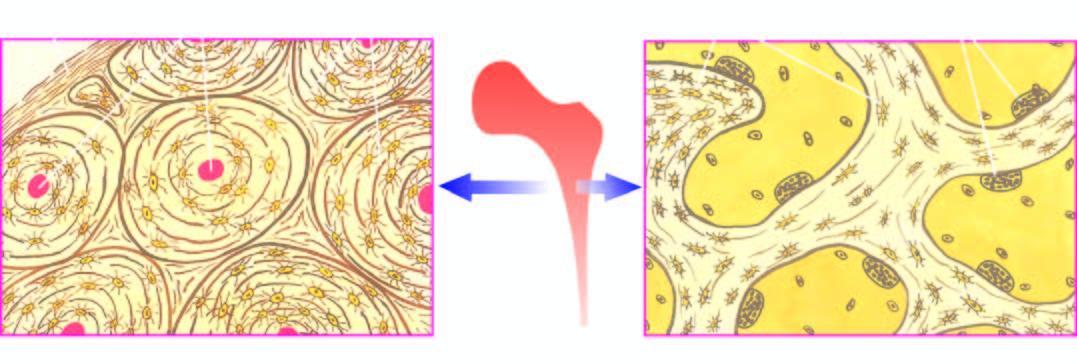does the upper dermis show trabeculae with osteoclastic activity at the margins?
Answer the question using a single word or phrase. No 